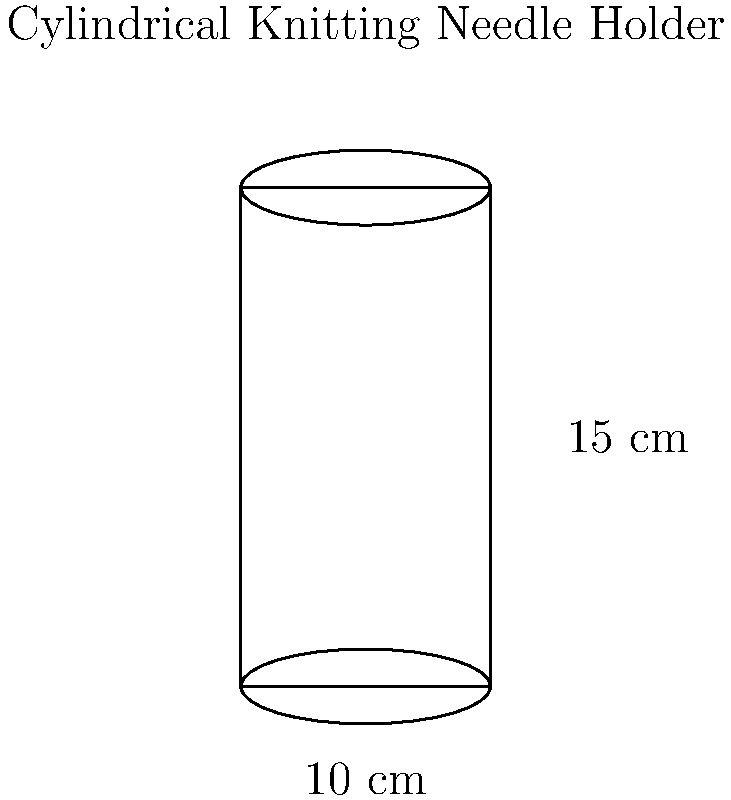You want to create a cylindrical holder for your knitting needles using some leftover fabric. The holder has a diameter of 10 cm and a height of 15 cm. Calculate the total surface area of fabric needed to make this holder, including the circular top and bottom. Round your answer to the nearest square centimeter. Let's approach this step-by-step:

1) The surface area of a cylinder consists of three parts:
   - The lateral surface (side)
   - The top circular surface
   - The bottom circular surface

2) For the lateral surface:
   - Circumference of the base = $\pi d = \pi \times 10 = 10\pi$ cm
   - Height = 15 cm
   - Area of lateral surface = $10\pi \times 15 = 150\pi$ cm²

3) For the top and bottom circular surfaces:
   - Radius = diameter ÷ 2 = 10 ÷ 2 = 5 cm
   - Area of one circular surface = $\pi r^2 = \pi \times 5^2 = 25\pi$ cm²
   - Area of both circular surfaces = $2 \times 25\pi = 50\pi$ cm²

4) Total surface area:
   - Total = Lateral surface + Top surface + Bottom surface
   - Total = $150\pi + 50\pi = 200\pi$ cm²

5) Calculate and round to the nearest cm²:
   $200\pi \approx 628.32$ cm²
   Rounded to the nearest cm² = 628 cm²
Answer: 628 cm² 